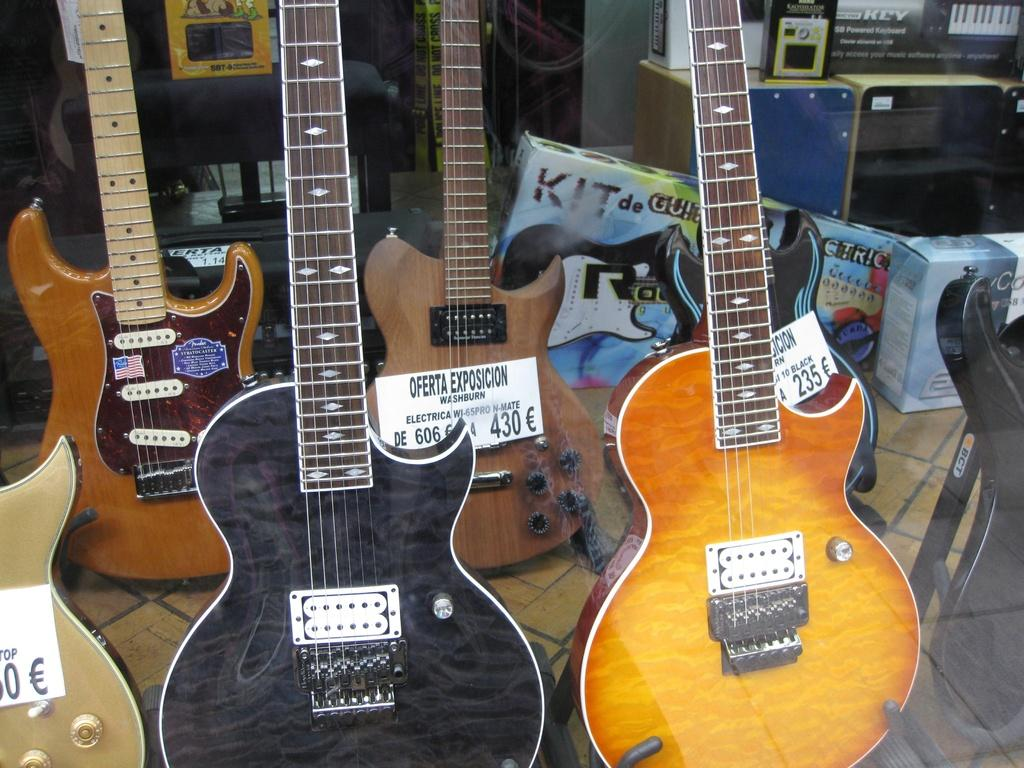What type of musical instruments are in the image? There are guitars in the image. Where are the guitars located? The guitars are in a shop. How can a potential buyer know the price of the guitars? There are price tags on the guitars. Can you see a crowd of people gathered around the guitars in the image? There is no crowd of people gathered around the guitars in the image. Are there any flames visible near the guitars in the image? There are no flames visible near the guitars in the image. 